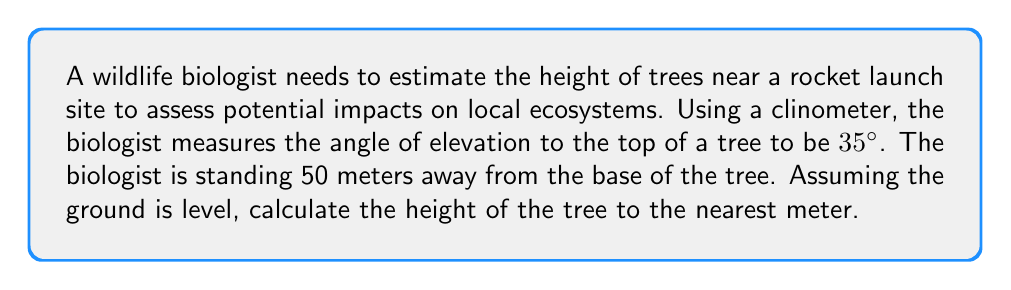Can you answer this question? To solve this problem, we can use trigonometry, specifically the tangent function. Let's break it down step-by-step:

1. Draw a right triangle representing the situation:
[asy]
import geometry;

size(200);
pair A = (0,0), B = (5,0), C = (5,3.5);
draw(A--B--C--A);
draw(rightangle(A,B,C,20));
label("50 m", (A--B), S);
label("Tree height", (B--C), E);
label("35°", A, SW);
[/asy]

2. Identify the known values:
   - The angle of elevation (θ) = 35°
   - The distance from the biologist to the tree (adjacent side) = 50 meters

3. Recall the tangent function:
   $$ \tan \theta = \frac{\text{opposite}}{\text{adjacent}} $$

4. In this case, we want to find the opposite side (tree height). Let's call it h:
   $$ \tan 35° = \frac{h}{50} $$

5. Rearrange the equation to solve for h:
   $$ h = 50 \tan 35° $$

6. Calculate the result:
   $$ h = 50 \times \tan 35° $$
   $$ h = 50 \times 0.7002 $$
   $$ h = 35.01 \text{ meters} $$

7. Round to the nearest meter:
   $$ h \approx 35 \text{ meters} $$
Answer: The height of the tree is approximately 35 meters. 